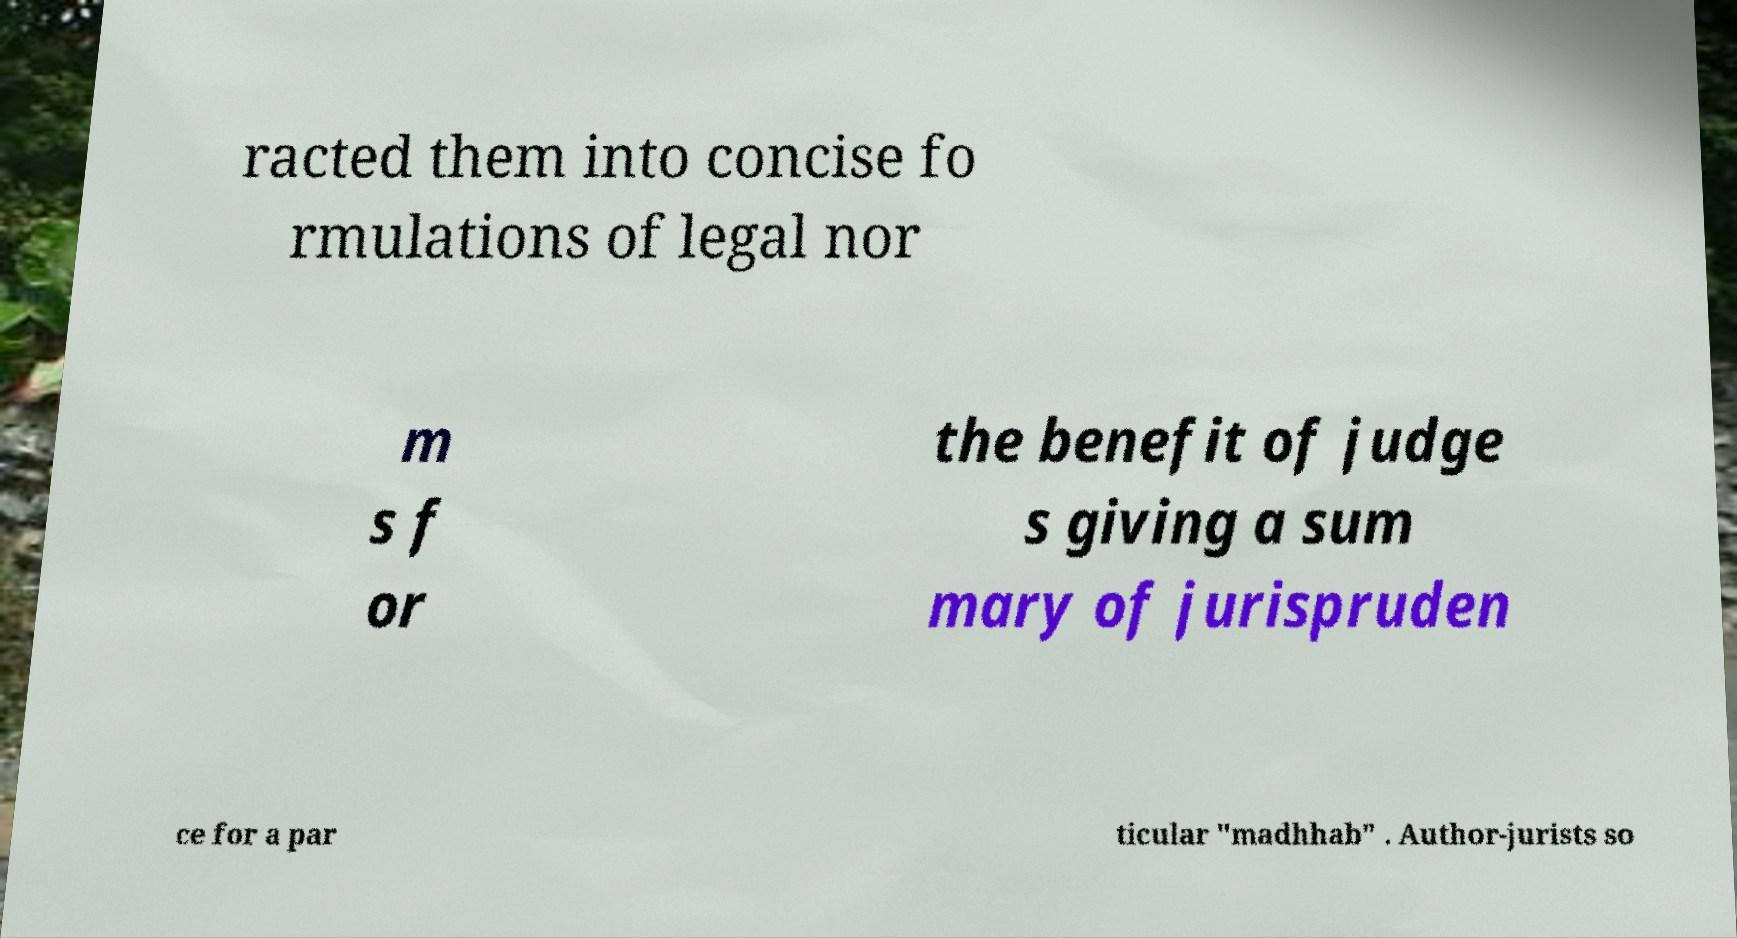What messages or text are displayed in this image? I need them in a readable, typed format. racted them into concise fo rmulations of legal nor m s f or the benefit of judge s giving a sum mary of jurispruden ce for a par ticular "madhhab" . Author-jurists so 